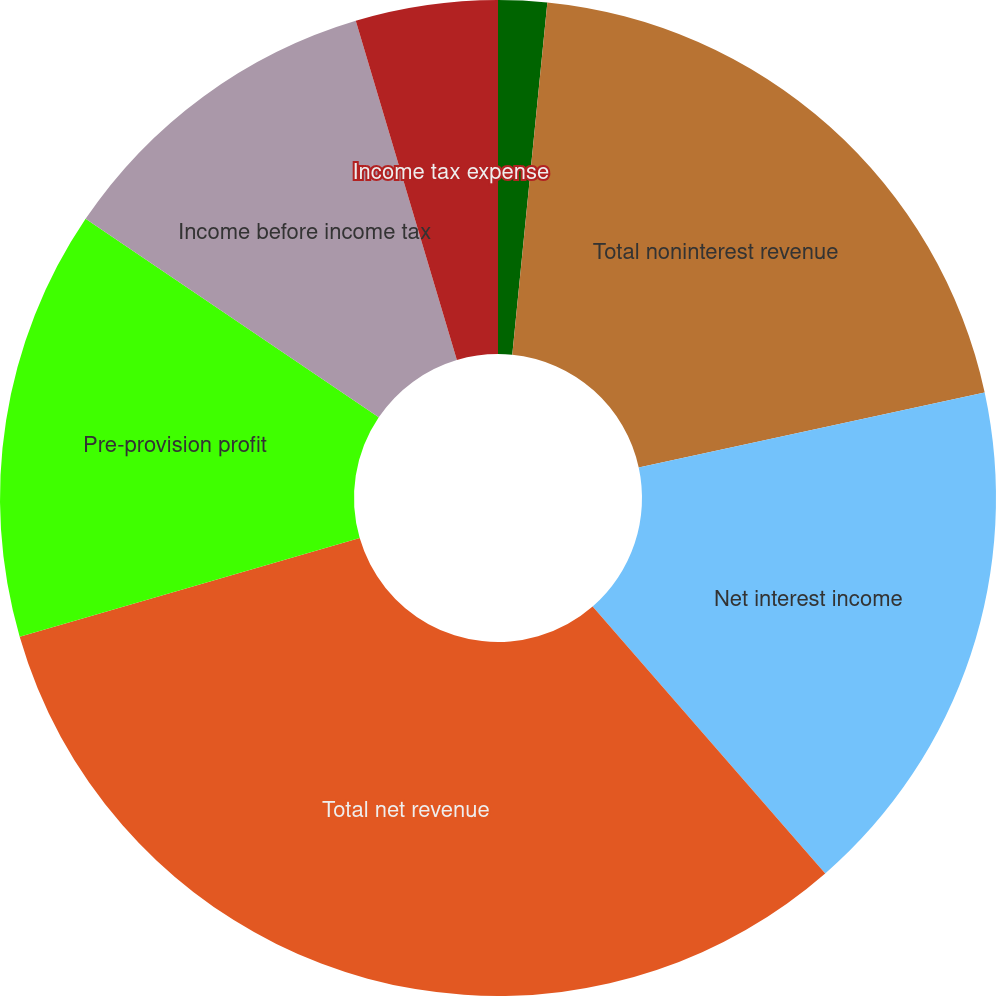<chart> <loc_0><loc_0><loc_500><loc_500><pie_chart><fcel>Other income<fcel>Total noninterest revenue<fcel>Net interest income<fcel>Total net revenue<fcel>Pre-provision profit<fcel>Income before income tax<fcel>Income tax expense<nl><fcel>1.58%<fcel>20.02%<fcel>16.99%<fcel>31.92%<fcel>13.96%<fcel>10.92%<fcel>4.61%<nl></chart> 